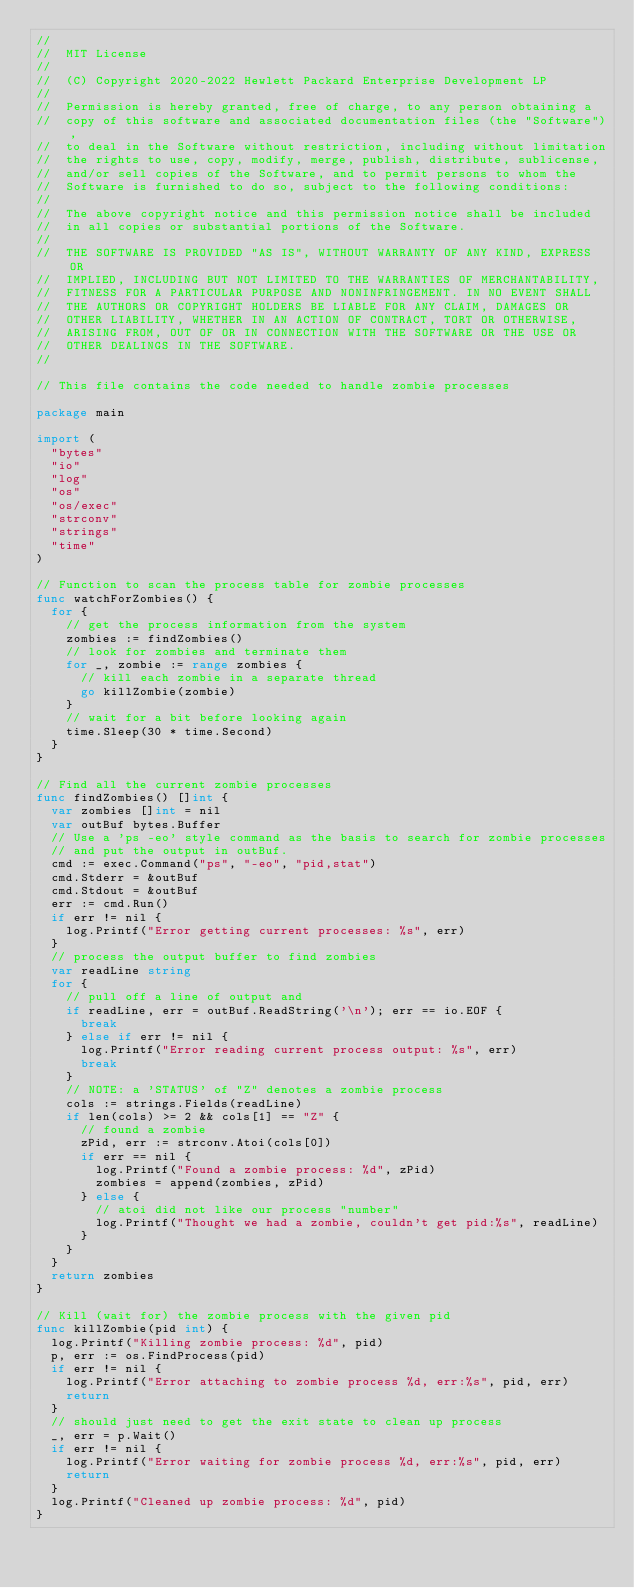<code> <loc_0><loc_0><loc_500><loc_500><_Go_>//
//  MIT License
//
//  (C) Copyright 2020-2022 Hewlett Packard Enterprise Development LP
//
//  Permission is hereby granted, free of charge, to any person obtaining a
//  copy of this software and associated documentation files (the "Software"),
//  to deal in the Software without restriction, including without limitation
//  the rights to use, copy, modify, merge, publish, distribute, sublicense,
//  and/or sell copies of the Software, and to permit persons to whom the
//  Software is furnished to do so, subject to the following conditions:
//
//  The above copyright notice and this permission notice shall be included
//  in all copies or substantial portions of the Software.
//
//  THE SOFTWARE IS PROVIDED "AS IS", WITHOUT WARRANTY OF ANY KIND, EXPRESS OR
//  IMPLIED, INCLUDING BUT NOT LIMITED TO THE WARRANTIES OF MERCHANTABILITY,
//  FITNESS FOR A PARTICULAR PURPOSE AND NONINFRINGEMENT. IN NO EVENT SHALL
//  THE AUTHORS OR COPYRIGHT HOLDERS BE LIABLE FOR ANY CLAIM, DAMAGES OR
//  OTHER LIABILITY, WHETHER IN AN ACTION OF CONTRACT, TORT OR OTHERWISE,
//  ARISING FROM, OUT OF OR IN CONNECTION WITH THE SOFTWARE OR THE USE OR
//  OTHER DEALINGS IN THE SOFTWARE.
//

// This file contains the code needed to handle zombie processes

package main

import (
	"bytes"
	"io"
	"log"
	"os"
	"os/exec"
	"strconv"
	"strings"
	"time"
)

// Function to scan the process table for zombie processes
func watchForZombies() {
	for {
		// get the process information from the system
		zombies := findZombies()
		// look for zombies and terminate them
		for _, zombie := range zombies {
			// kill each zombie in a separate thread
			go killZombie(zombie)
		}
		// wait for a bit before looking again
		time.Sleep(30 * time.Second)
	}
}

// Find all the current zombie processes
func findZombies() []int {
	var zombies []int = nil
	var outBuf bytes.Buffer
	// Use a 'ps -eo' style command as the basis to search for zombie processes
	// and put the output in outBuf.
	cmd := exec.Command("ps", "-eo", "pid,stat")
	cmd.Stderr = &outBuf
	cmd.Stdout = &outBuf
	err := cmd.Run()
	if err != nil {
		log.Printf("Error getting current processes: %s", err)
	}
	// process the output buffer to find zombies
	var readLine string
	for {
		// pull off a line of output and
		if readLine, err = outBuf.ReadString('\n'); err == io.EOF {
			break
		} else if err != nil {
			log.Printf("Error reading current process output: %s", err)
			break
		}
		// NOTE: a 'STATUS' of "Z" denotes a zombie process
		cols := strings.Fields(readLine)
		if len(cols) >= 2 && cols[1] == "Z" {
			// found a zombie
			zPid, err := strconv.Atoi(cols[0])
			if err == nil {
				log.Printf("Found a zombie process: %d", zPid)
				zombies = append(zombies, zPid)
			} else {
				// atoi did not like our process "number"
				log.Printf("Thought we had a zombie, couldn't get pid:%s", readLine)
			}
		}
	}
	return zombies
}

// Kill (wait for) the zombie process with the given pid
func killZombie(pid int) {
	log.Printf("Killing zombie process: %d", pid)
	p, err := os.FindProcess(pid)
	if err != nil {
		log.Printf("Error attaching to zombie process %d, err:%s", pid, err)
		return
	}
	// should just need to get the exit state to clean up process
	_, err = p.Wait()
	if err != nil {
		log.Printf("Error waiting for zombie process %d, err:%s", pid, err)
		return
	}
	log.Printf("Cleaned up zombie process: %d", pid)
}
</code> 